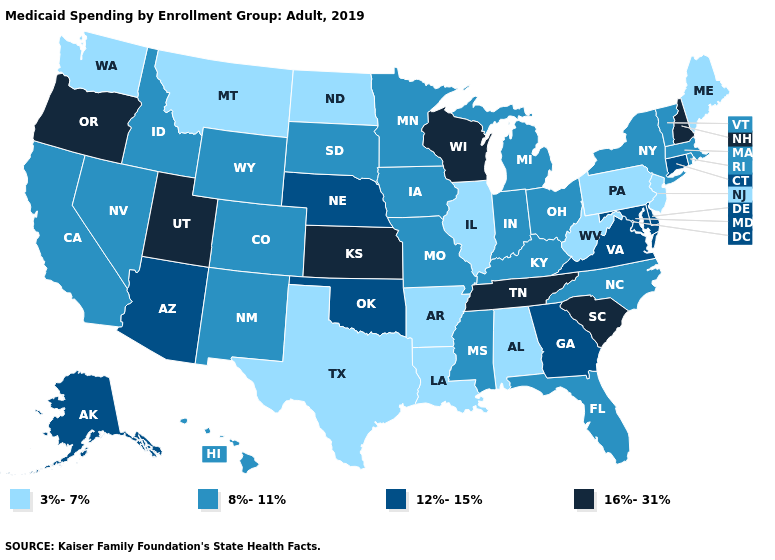What is the value of Texas?
Be succinct. 3%-7%. What is the lowest value in the Northeast?
Be succinct. 3%-7%. What is the value of Arkansas?
Write a very short answer. 3%-7%. Does Maine have the highest value in the USA?
Concise answer only. No. Name the states that have a value in the range 3%-7%?
Concise answer only. Alabama, Arkansas, Illinois, Louisiana, Maine, Montana, New Jersey, North Dakota, Pennsylvania, Texas, Washington, West Virginia. Does the first symbol in the legend represent the smallest category?
Give a very brief answer. Yes. What is the value of Minnesota?
Keep it brief. 8%-11%. What is the value of Idaho?
Keep it brief. 8%-11%. What is the highest value in the USA?
Short answer required. 16%-31%. Does Kansas have the highest value in the USA?
Write a very short answer. Yes. What is the value of Kansas?
Keep it brief. 16%-31%. Which states have the lowest value in the USA?
Concise answer only. Alabama, Arkansas, Illinois, Louisiana, Maine, Montana, New Jersey, North Dakota, Pennsylvania, Texas, Washington, West Virginia. Does the map have missing data?
Give a very brief answer. No. Does Idaho have the lowest value in the West?
Keep it brief. No. Name the states that have a value in the range 8%-11%?
Keep it brief. California, Colorado, Florida, Hawaii, Idaho, Indiana, Iowa, Kentucky, Massachusetts, Michigan, Minnesota, Mississippi, Missouri, Nevada, New Mexico, New York, North Carolina, Ohio, Rhode Island, South Dakota, Vermont, Wyoming. 